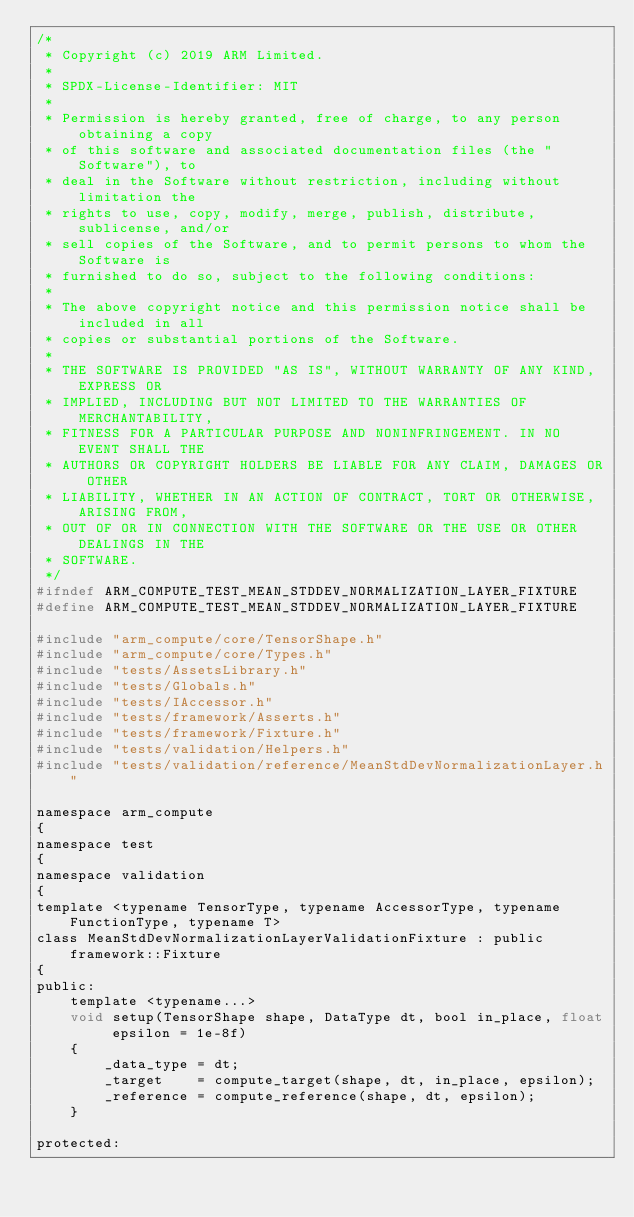Convert code to text. <code><loc_0><loc_0><loc_500><loc_500><_C_>/*
 * Copyright (c) 2019 ARM Limited.
 *
 * SPDX-License-Identifier: MIT
 *
 * Permission is hereby granted, free of charge, to any person obtaining a copy
 * of this software and associated documentation files (the "Software"), to
 * deal in the Software without restriction, including without limitation the
 * rights to use, copy, modify, merge, publish, distribute, sublicense, and/or
 * sell copies of the Software, and to permit persons to whom the Software is
 * furnished to do so, subject to the following conditions:
 *
 * The above copyright notice and this permission notice shall be included in all
 * copies or substantial portions of the Software.
 *
 * THE SOFTWARE IS PROVIDED "AS IS", WITHOUT WARRANTY OF ANY KIND, EXPRESS OR
 * IMPLIED, INCLUDING BUT NOT LIMITED TO THE WARRANTIES OF MERCHANTABILITY,
 * FITNESS FOR A PARTICULAR PURPOSE AND NONINFRINGEMENT. IN NO EVENT SHALL THE
 * AUTHORS OR COPYRIGHT HOLDERS BE LIABLE FOR ANY CLAIM, DAMAGES OR OTHER
 * LIABILITY, WHETHER IN AN ACTION OF CONTRACT, TORT OR OTHERWISE, ARISING FROM,
 * OUT OF OR IN CONNECTION WITH THE SOFTWARE OR THE USE OR OTHER DEALINGS IN THE
 * SOFTWARE.
 */
#ifndef ARM_COMPUTE_TEST_MEAN_STDDEV_NORMALIZATION_LAYER_FIXTURE
#define ARM_COMPUTE_TEST_MEAN_STDDEV_NORMALIZATION_LAYER_FIXTURE

#include "arm_compute/core/TensorShape.h"
#include "arm_compute/core/Types.h"
#include "tests/AssetsLibrary.h"
#include "tests/Globals.h"
#include "tests/IAccessor.h"
#include "tests/framework/Asserts.h"
#include "tests/framework/Fixture.h"
#include "tests/validation/Helpers.h"
#include "tests/validation/reference/MeanStdDevNormalizationLayer.h"

namespace arm_compute
{
namespace test
{
namespace validation
{
template <typename TensorType, typename AccessorType, typename FunctionType, typename T>
class MeanStdDevNormalizationLayerValidationFixture : public framework::Fixture
{
public:
    template <typename...>
    void setup(TensorShape shape, DataType dt, bool in_place, float epsilon = 1e-8f)
    {
        _data_type = dt;
        _target    = compute_target(shape, dt, in_place, epsilon);
        _reference = compute_reference(shape, dt, epsilon);
    }

protected:</code> 